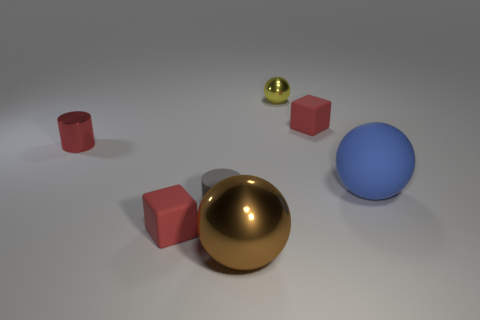There is a big thing left of the large matte ball; what is its shape?
Your response must be concise. Sphere. Is there anything else that is the same color as the big metallic object?
Make the answer very short. No. Are there fewer brown things that are behind the small yellow thing than gray cylinders?
Offer a very short reply. Yes. What number of gray rubber things have the same size as the brown object?
Provide a succinct answer. 0. What is the shape of the gray thing in front of the shiny thing behind the small red rubber object on the right side of the yellow sphere?
Your answer should be compact. Cylinder. There is a cylinder that is to the left of the tiny gray rubber thing; what is its color?
Provide a short and direct response. Red. How many objects are small rubber objects that are in front of the tiny red cylinder or tiny cylinders behind the blue ball?
Your answer should be compact. 3. What number of big cyan matte objects have the same shape as the large brown shiny thing?
Your answer should be very brief. 0. What color is the metal sphere that is the same size as the red cylinder?
Offer a terse response. Yellow. There is a matte cylinder right of the red matte thing to the left of the tiny metal thing on the right side of the red cylinder; what is its color?
Make the answer very short. Gray. 